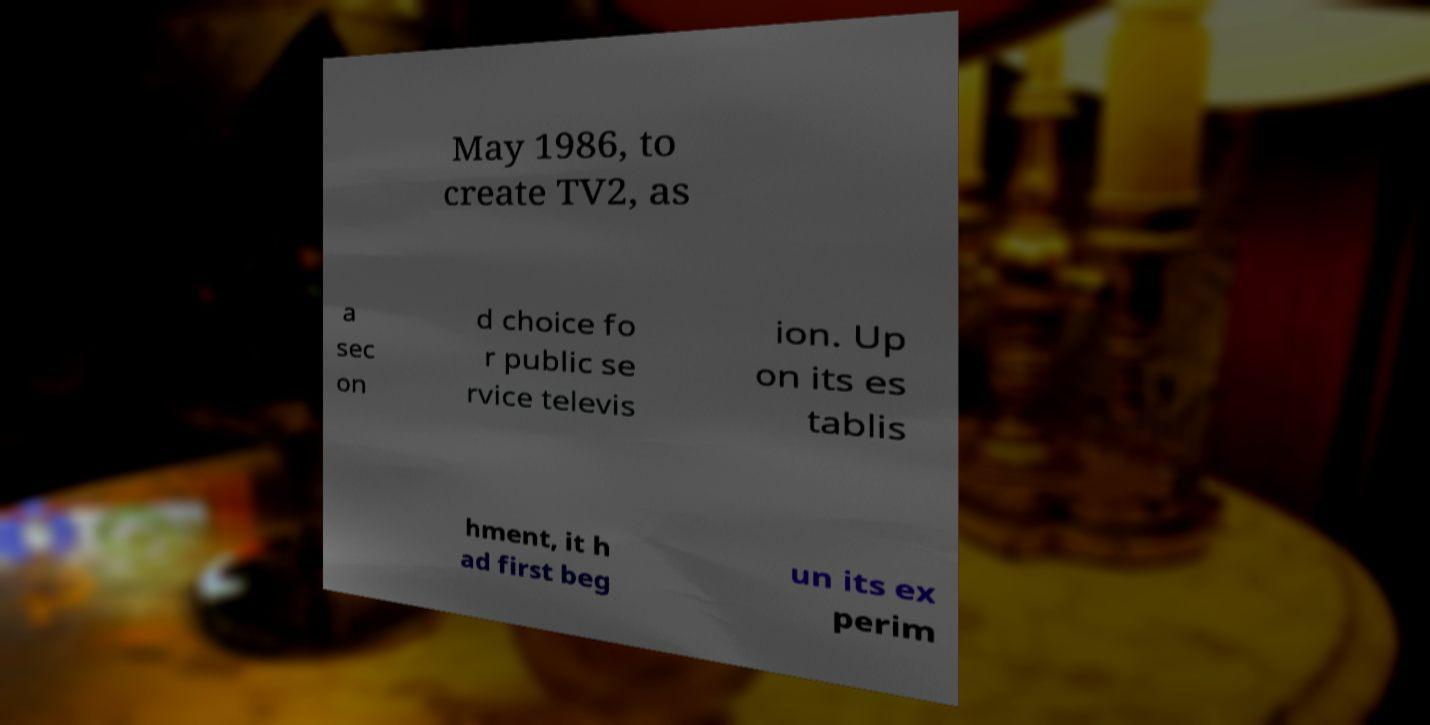Can you accurately transcribe the text from the provided image for me? May 1986, to create TV2, as a sec on d choice fo r public se rvice televis ion. Up on its es tablis hment, it h ad first beg un its ex perim 